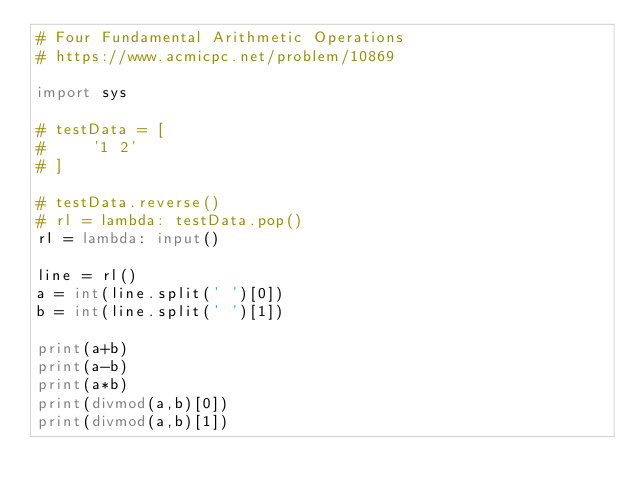Convert code to text. <code><loc_0><loc_0><loc_500><loc_500><_Python_># Four Fundamental Arithmetic Operations
# https://www.acmicpc.net/problem/10869

import sys

# testData = [
#     '1 2'
# ]

# testData.reverse()
# rl = lambda: testData.pop()
rl = lambda: input()

line = rl()
a = int(line.split(' ')[0])
b = int(line.split(' ')[1])

print(a+b)
print(a-b)
print(a*b)
print(divmod(a,b)[0])
print(divmod(a,b)[1])
</code> 